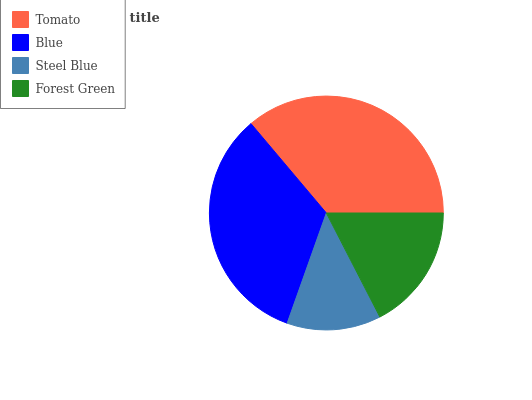Is Steel Blue the minimum?
Answer yes or no. Yes. Is Tomato the maximum?
Answer yes or no. Yes. Is Blue the minimum?
Answer yes or no. No. Is Blue the maximum?
Answer yes or no. No. Is Tomato greater than Blue?
Answer yes or no. Yes. Is Blue less than Tomato?
Answer yes or no. Yes. Is Blue greater than Tomato?
Answer yes or no. No. Is Tomato less than Blue?
Answer yes or no. No. Is Blue the high median?
Answer yes or no. Yes. Is Forest Green the low median?
Answer yes or no. Yes. Is Forest Green the high median?
Answer yes or no. No. Is Steel Blue the low median?
Answer yes or no. No. 